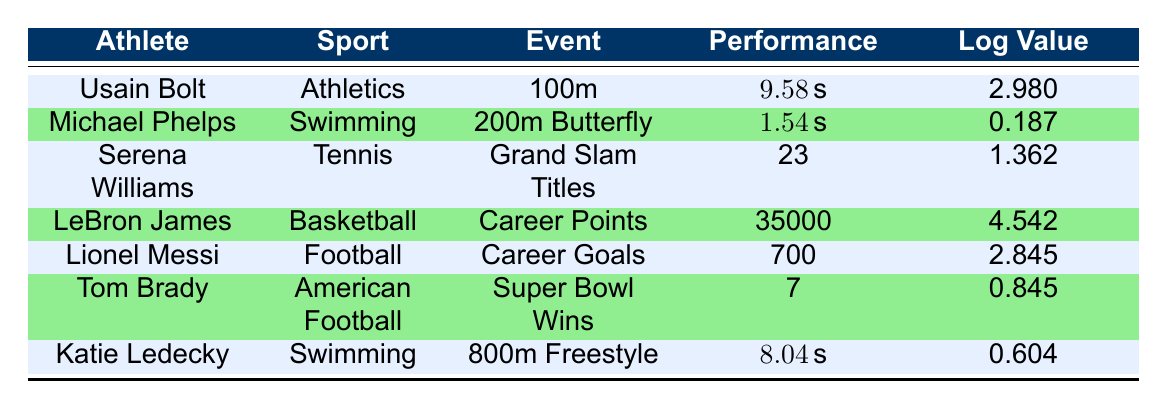What was Usain Bolt's performance time in the 100m event? The table directly lists Usain Bolt's performance time for the 100m event as 9.58 seconds.
Answer: 9.58 seconds Which athlete has the highest logarithmic performance time? To find the athlete with the highest logarithmic performance time, we compare the log values in the table: 2.980 (Usain Bolt), 0.187 (Michael Phelps), 1.362 (Serena Williams), 4.542 (LeBron James), 2.845 (Lionel Messi), 0.845 (Tom Brady), and 0.604 (Katie Ledecky). LeBron James has the highest log value at 4.542.
Answer: LeBron James How many Grand Slam titles has Serena Williams won? The table shows that Serena Williams has won a total of 23 Grand Slam titles.
Answer: 23 Is Lionel Messi's total goals greater than Tom Brady's Super Bowl wins? The table states Lionel Messi has 700 total goals and Tom Brady has 7 Super Bowl wins. Since 700 is greater than 7, the statement is true.
Answer: Yes What is the difference between the total points of LeBron James and total goals of Lionel Messi? LeBron James has a total of 35,000 points, and Lionel Messi has 700 goals. To find the difference, subtract 700 from 35,000: 35,000 - 700 = 34,300.
Answer: 34,300 Which sport has the athlete with the lowest logarithmic performance value? From the log values provided in the table, Michael Phelps has the lowest value at 0.187. He participates in Swimming, which indicates that Swimming is the sport with the lowest log value.
Answer: Swimming What is the average of the total titles won by Serena Williams and the total wins of Tom Brady? Serena Williams has 23 titles, and Tom Brady has 7 wins. To find the average, sum these values (23 + 7 = 30) and then divide by 2: 30 / 2 = 15.
Answer: 15 Is Katie Ledecky's performance time in the 800m freestyle faster than Usain Bolt's performance time in the 100m? Katie Ledecky's performance time is 8.04 seconds while Usain Bolt's is 9.58 seconds. Since 8.04 seconds is less than 9.58 seconds, the statement is false.
Answer: No What is the sum of all the log performance values in the table? The log values are 2.980, 0.187, 1.362, 4.542, 2.845, 0.845, and 0.604. Adding them together gives 2.980 + 0.187 + 1.362 + 4.542 + 2.845 + 0.845 + 0.604 = 13.565.
Answer: 13.565 